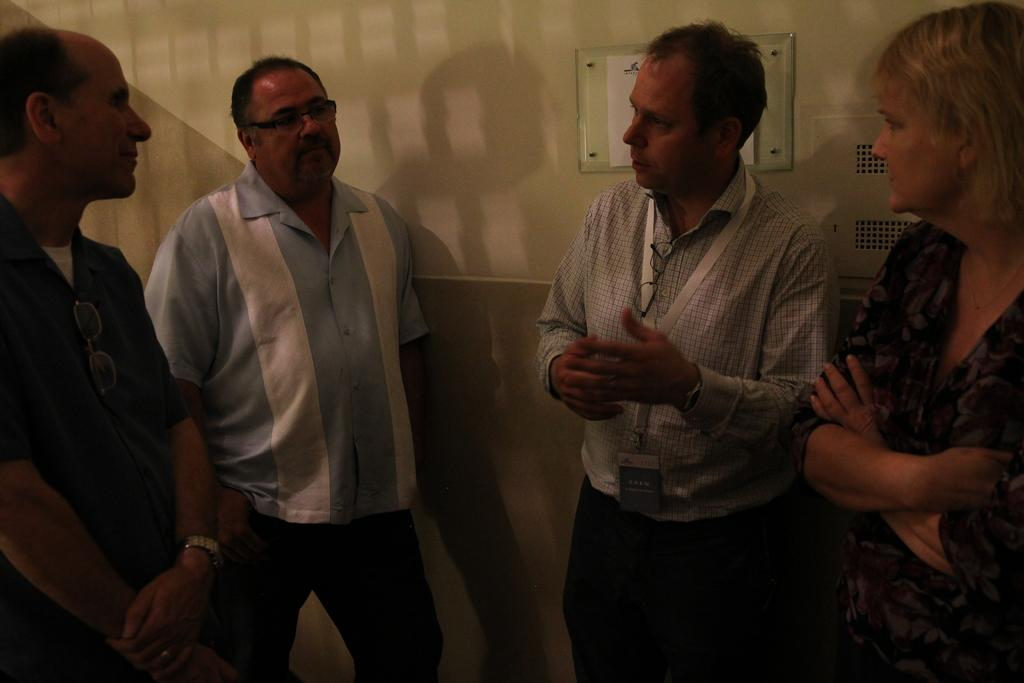What is happening in the image? There is a group of people in the image, and they are standing and talking to each other. How are the people interacting with each other? The people are talking to each other, which suggests they are engaged in conversation or communication. What type of store can be seen in the background of the image? There is no store present in the image; it only features a group of people standing and talking to each other. 